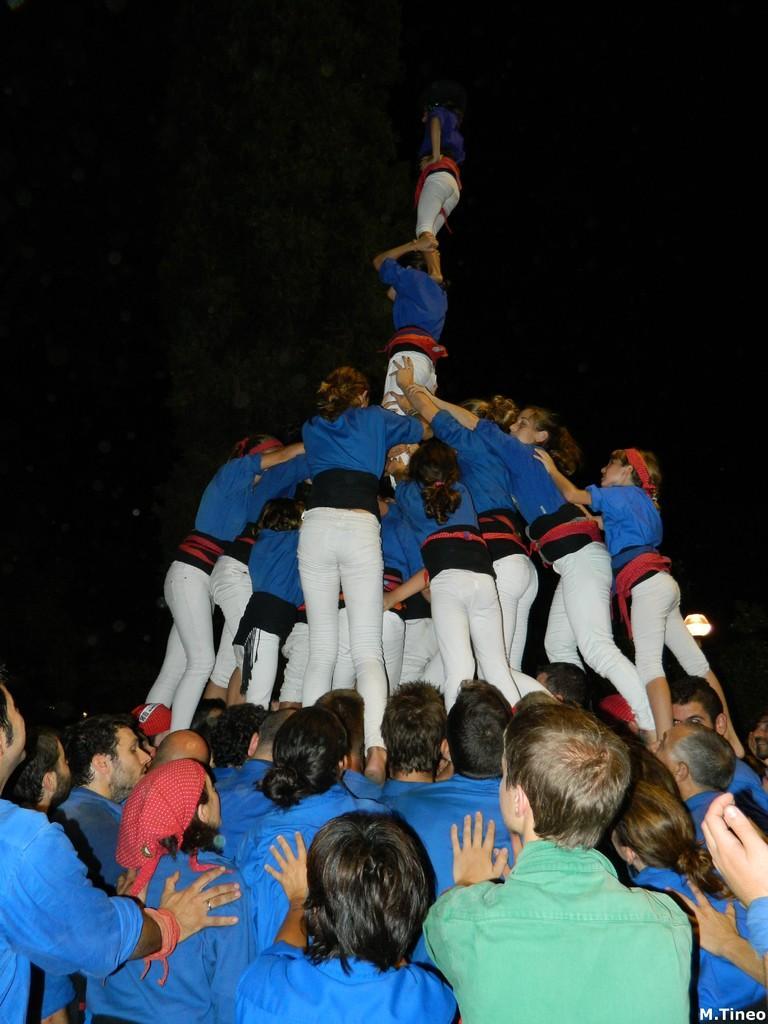Please provide a concise description of this image. In the picture we can see some people are standing on them and some people are climbed and standing on step by step, they are wearing a blue T-shirts with white trousers and one man is wearing a green T-shirt and in the background we can see a dark. 